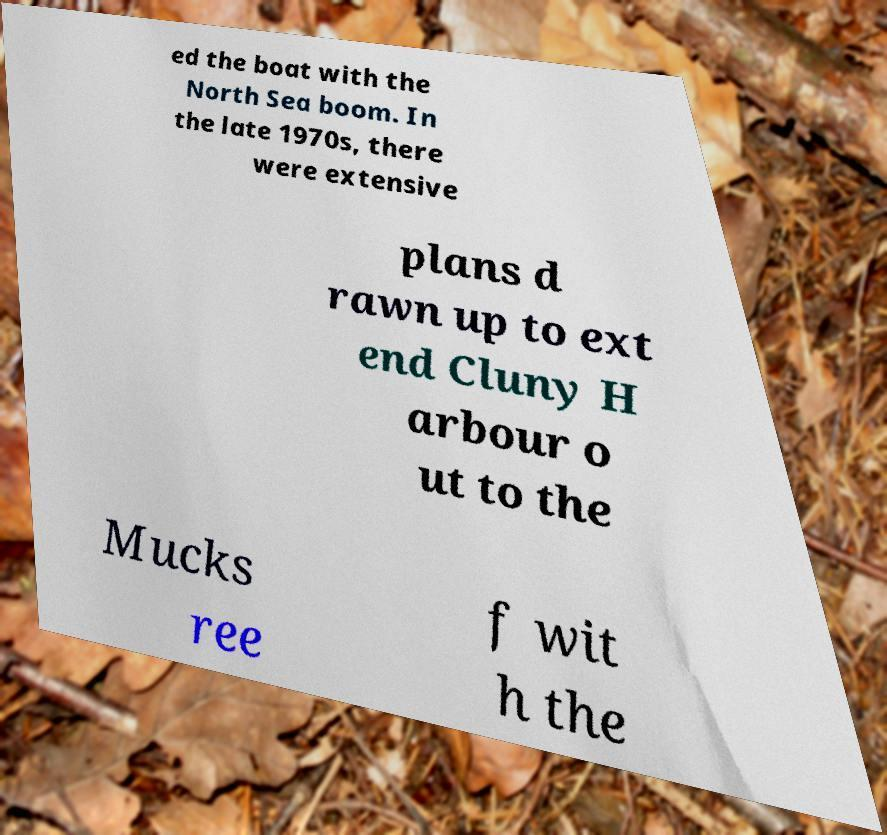There's text embedded in this image that I need extracted. Can you transcribe it verbatim? ed the boat with the North Sea boom. In the late 1970s, there were extensive plans d rawn up to ext end Cluny H arbour o ut to the Mucks ree f wit h the 